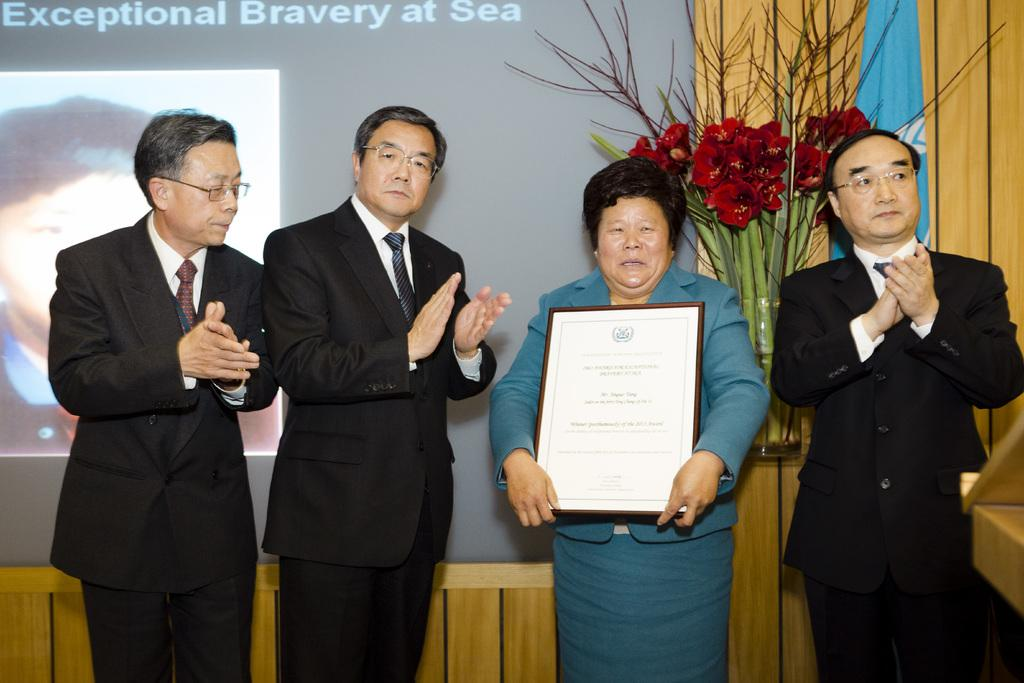How many people are in the image? There are people in the image, but the exact number is not specified. What is the woman holding in the image? The woman is holding a frame in the image. What can be seen in the background of the image? There is a display visible in the image. What type of plant is in the image? There is a potted plant in the image. What type of pleasure can be seen on the faces of the people in the image? There is no information about the expressions or feelings of the people in the image, so it is not possible to determine their pleasure. 